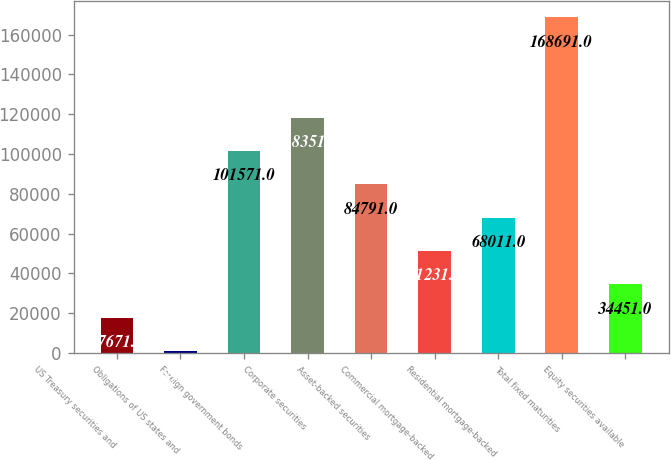Convert chart. <chart><loc_0><loc_0><loc_500><loc_500><bar_chart><fcel>US Treasury securities and<fcel>Obligations of US states and<fcel>Foreign government bonds<fcel>Corporate securities<fcel>Asset-backed securities<fcel>Commercial mortgage-backed<fcel>Residential mortgage-backed<fcel>Total fixed maturities<fcel>Equity securities available<nl><fcel>17671<fcel>891<fcel>101571<fcel>118351<fcel>84791<fcel>51231<fcel>68011<fcel>168691<fcel>34451<nl></chart> 